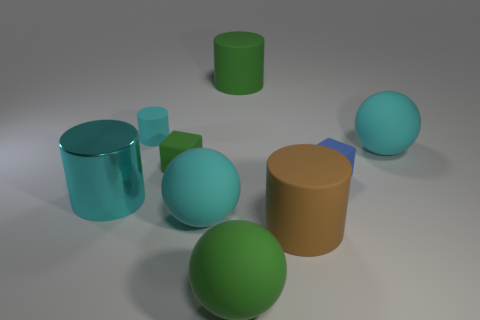Add 1 big brown matte cylinders. How many objects exist? 10 Subtract all cylinders. How many objects are left? 5 Add 7 green rubber things. How many green rubber things exist? 10 Subtract 0 blue cylinders. How many objects are left? 9 Subtract all blue rubber blocks. Subtract all big balls. How many objects are left? 5 Add 3 green rubber balls. How many green rubber balls are left? 4 